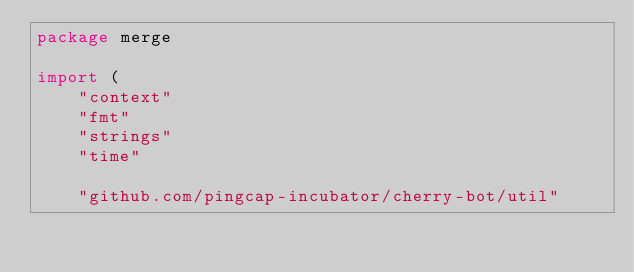Convert code to text. <code><loc_0><loc_0><loc_500><loc_500><_Go_>package merge

import (
	"context"
	"fmt"
	"strings"
	"time"

	"github.com/pingcap-incubator/cherry-bot/util"
</code> 